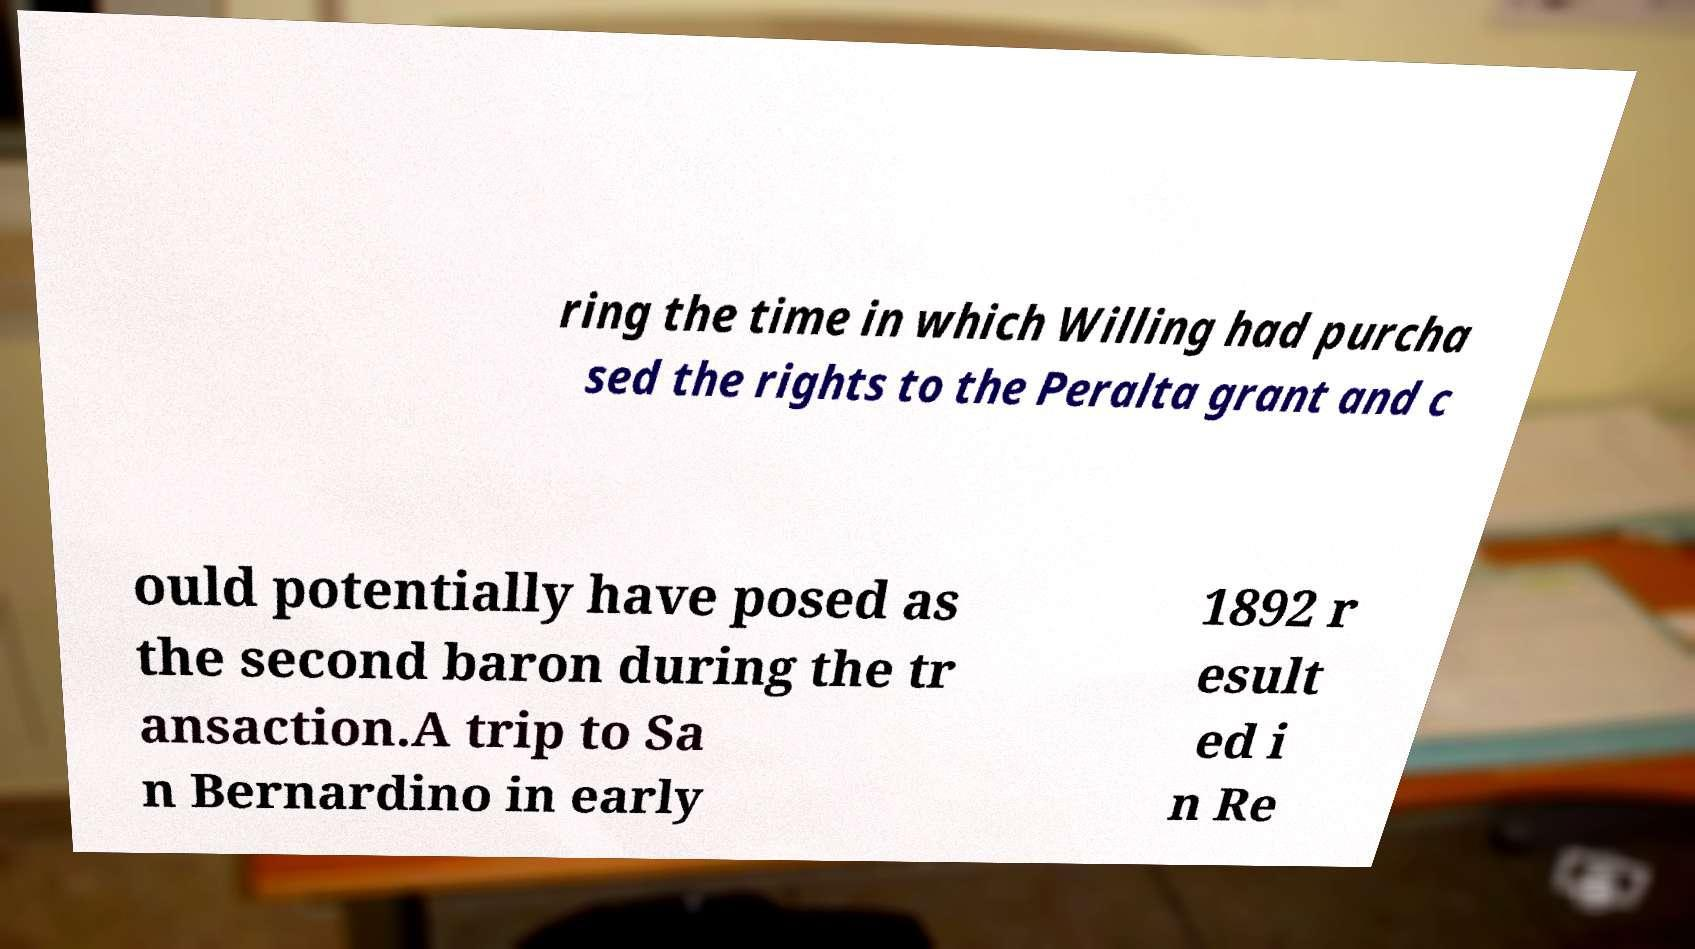Please read and relay the text visible in this image. What does it say? ring the time in which Willing had purcha sed the rights to the Peralta grant and c ould potentially have posed as the second baron during the tr ansaction.A trip to Sa n Bernardino in early 1892 r esult ed i n Re 